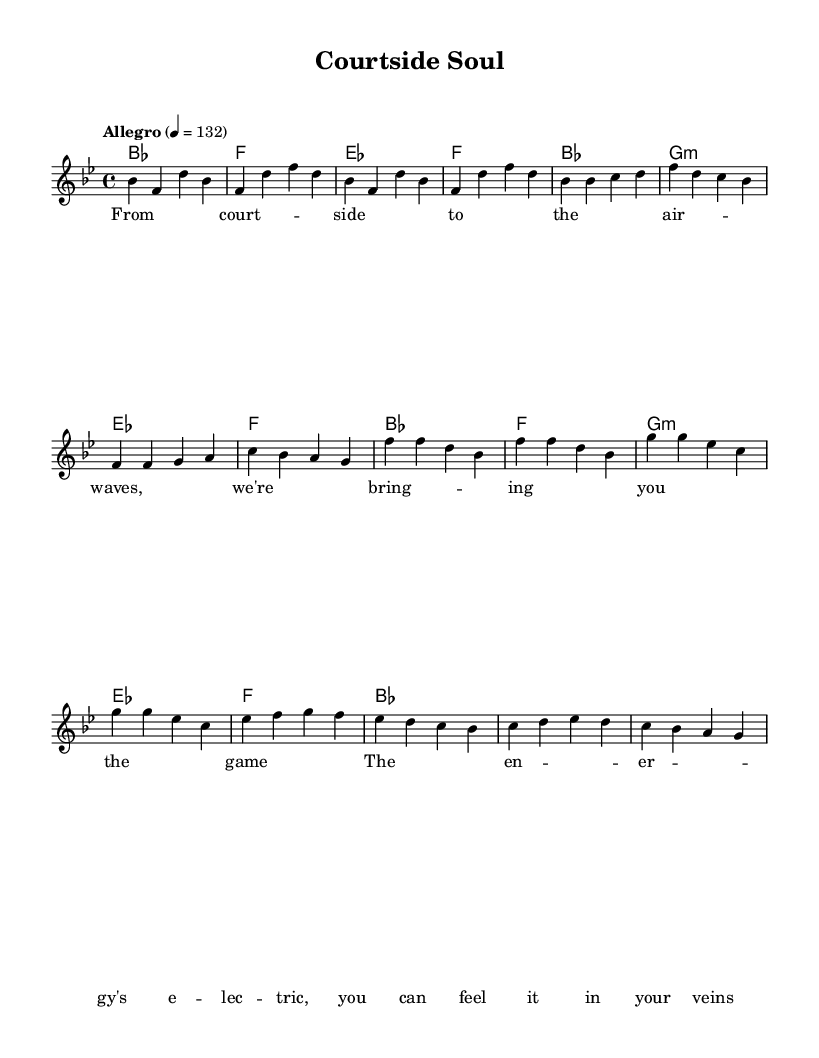What is the key signature of this music? The key signature is indicated at the beginning of the staff and shows two flat notes, which indicates that the key is B flat major.
Answer: B flat major What is the time signature of this music? The time signature appears at the beginning of the score and reads 4/4, which means there are four beats in each measure and a quarter note receives one beat.
Answer: 4/4 What is the tempo marking of this piece? The tempo marking uses the Italian word "Allegro," which indicates a lively and fast pace, specifically stating the metronome marking of 132 beats per minute.
Answer: Allegro, 132 How many measures are in the melody section? Counting the individual groups of four beats notated, we see there are a total of 12 measures in the melody section displayed.
Answer: 12 Which chord follows the first measure in harmonies? The chord is notated right after the vertical line marking the end of the first measure, showing that it is F major, as indicated by the single note F.
Answer: F What is the first line of the lyrics? The first line of the lyrics is shown beneath the melody, labeling the words "From court -- side to the air -- waves, we're bring -- ing you the game," directly reflecting the essence of live sports broadcasting.
Answer: From court -- side to the air -- waves, we're bring -- ing you the game What musical style is this piece representative of? The structure and rhythmic quality, along with lyrics reflecting energy and excitement, signifies its representation of the Soul music style, generally characterized by its expressive vocal delivery and upbeat rhythms.
Answer: Soul 